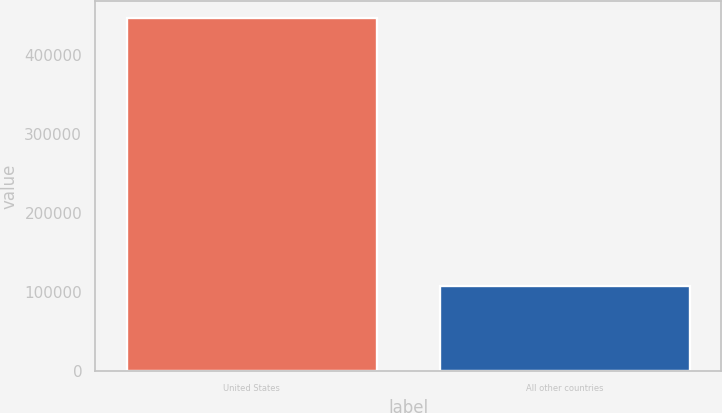Convert chart. <chart><loc_0><loc_0><loc_500><loc_500><bar_chart><fcel>United States<fcel>All other countries<nl><fcel>446044<fcel>107082<nl></chart> 